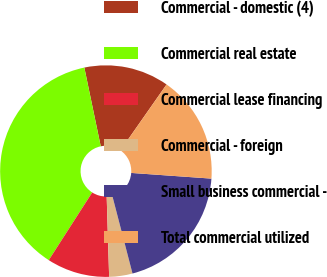Convert chart to OTSL. <chart><loc_0><loc_0><loc_500><loc_500><pie_chart><fcel>Commercial - domestic (4)<fcel>Commercial real estate<fcel>Commercial lease financing<fcel>Commercial - foreign<fcel>Small business commercial -<fcel>Total commercial utilized<nl><fcel>12.99%<fcel>37.65%<fcel>9.57%<fcel>3.56%<fcel>19.83%<fcel>16.41%<nl></chart> 